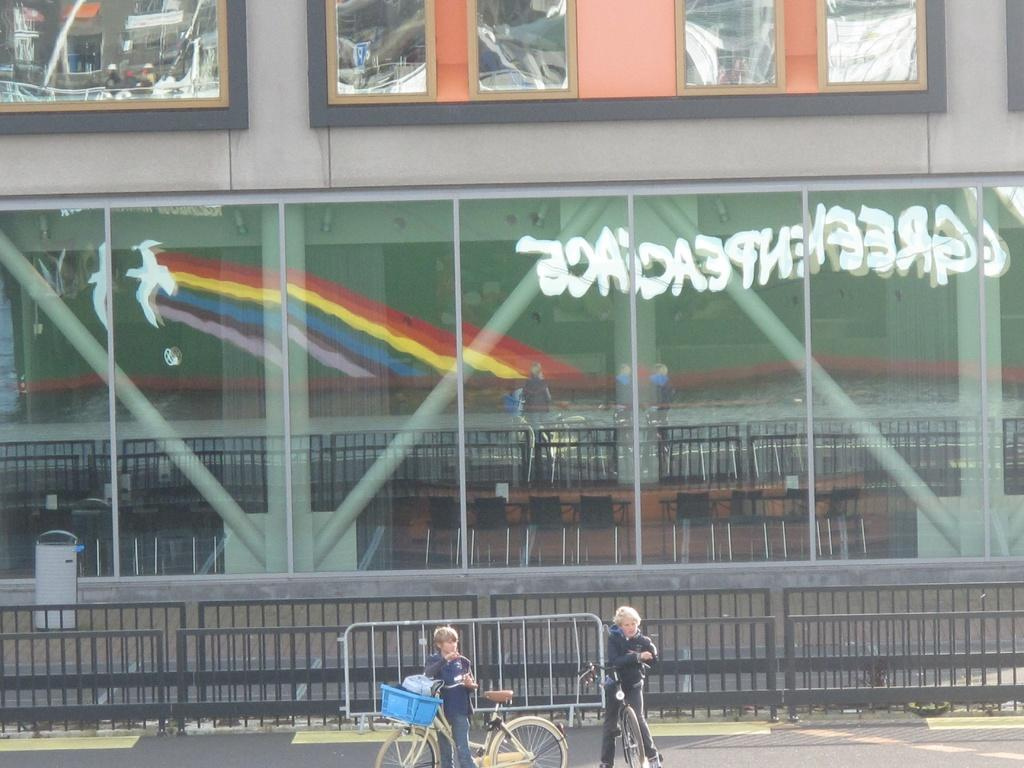<image>
Offer a succinct explanation of the picture presented. A reflection of the word greenpeace is on a green sign. 